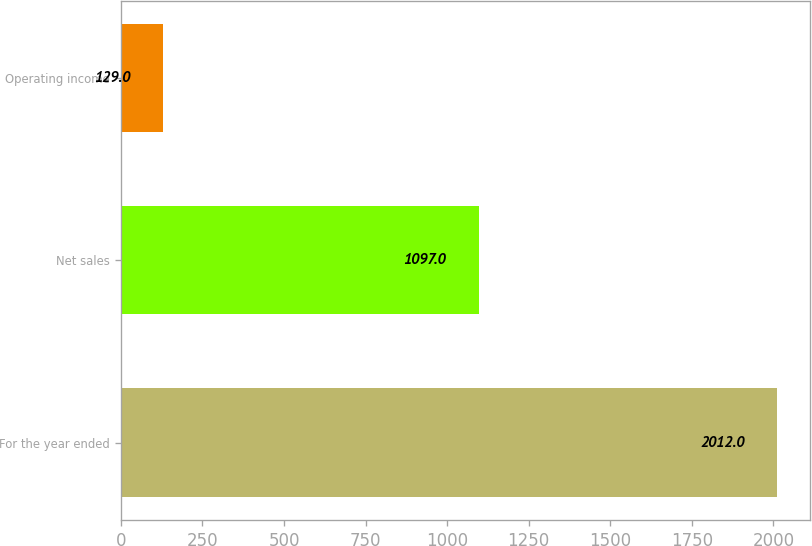Convert chart to OTSL. <chart><loc_0><loc_0><loc_500><loc_500><bar_chart><fcel>For the year ended<fcel>Net sales<fcel>Operating income<nl><fcel>2012<fcel>1097<fcel>129<nl></chart> 